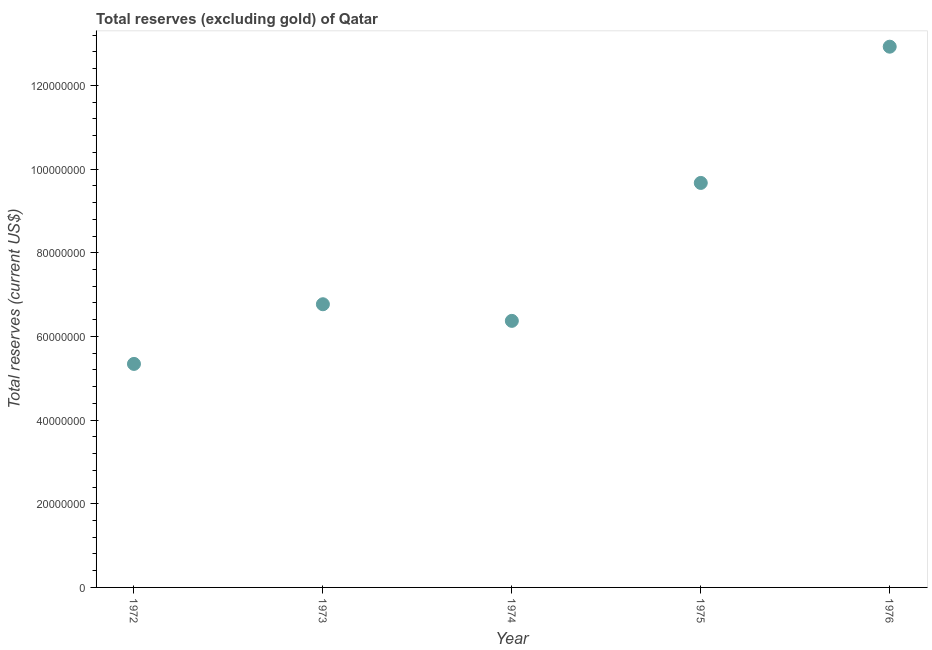What is the total reserves (excluding gold) in 1972?
Provide a short and direct response. 5.34e+07. Across all years, what is the maximum total reserves (excluding gold)?
Provide a short and direct response. 1.29e+08. Across all years, what is the minimum total reserves (excluding gold)?
Make the answer very short. 5.34e+07. In which year was the total reserves (excluding gold) maximum?
Your answer should be compact. 1976. In which year was the total reserves (excluding gold) minimum?
Ensure brevity in your answer.  1972. What is the sum of the total reserves (excluding gold)?
Offer a terse response. 4.11e+08. What is the difference between the total reserves (excluding gold) in 1972 and 1974?
Offer a very short reply. -1.03e+07. What is the average total reserves (excluding gold) per year?
Your answer should be very brief. 8.22e+07. What is the median total reserves (excluding gold)?
Offer a very short reply. 6.77e+07. What is the ratio of the total reserves (excluding gold) in 1974 to that in 1975?
Provide a short and direct response. 0.66. Is the difference between the total reserves (excluding gold) in 1973 and 1976 greater than the difference between any two years?
Provide a short and direct response. No. What is the difference between the highest and the second highest total reserves (excluding gold)?
Ensure brevity in your answer.  3.26e+07. What is the difference between the highest and the lowest total reserves (excluding gold)?
Give a very brief answer. 7.58e+07. In how many years, is the total reserves (excluding gold) greater than the average total reserves (excluding gold) taken over all years?
Make the answer very short. 2. How many dotlines are there?
Ensure brevity in your answer.  1. What is the difference between two consecutive major ticks on the Y-axis?
Give a very brief answer. 2.00e+07. Does the graph contain grids?
Offer a very short reply. No. What is the title of the graph?
Provide a succinct answer. Total reserves (excluding gold) of Qatar. What is the label or title of the Y-axis?
Your answer should be compact. Total reserves (current US$). What is the Total reserves (current US$) in 1972?
Ensure brevity in your answer.  5.34e+07. What is the Total reserves (current US$) in 1973?
Make the answer very short. 6.77e+07. What is the Total reserves (current US$) in 1974?
Offer a terse response. 6.37e+07. What is the Total reserves (current US$) in 1975?
Give a very brief answer. 9.67e+07. What is the Total reserves (current US$) in 1976?
Your response must be concise. 1.29e+08. What is the difference between the Total reserves (current US$) in 1972 and 1973?
Offer a very short reply. -1.43e+07. What is the difference between the Total reserves (current US$) in 1972 and 1974?
Provide a short and direct response. -1.03e+07. What is the difference between the Total reserves (current US$) in 1972 and 1975?
Make the answer very short. -4.33e+07. What is the difference between the Total reserves (current US$) in 1972 and 1976?
Ensure brevity in your answer.  -7.58e+07. What is the difference between the Total reserves (current US$) in 1973 and 1974?
Keep it short and to the point. 3.97e+06. What is the difference between the Total reserves (current US$) in 1973 and 1975?
Your response must be concise. -2.90e+07. What is the difference between the Total reserves (current US$) in 1973 and 1976?
Provide a short and direct response. -6.16e+07. What is the difference between the Total reserves (current US$) in 1974 and 1975?
Your answer should be compact. -3.30e+07. What is the difference between the Total reserves (current US$) in 1974 and 1976?
Give a very brief answer. -6.55e+07. What is the difference between the Total reserves (current US$) in 1975 and 1976?
Offer a very short reply. -3.26e+07. What is the ratio of the Total reserves (current US$) in 1972 to that in 1973?
Provide a short and direct response. 0.79. What is the ratio of the Total reserves (current US$) in 1972 to that in 1974?
Make the answer very short. 0.84. What is the ratio of the Total reserves (current US$) in 1972 to that in 1975?
Your answer should be very brief. 0.55. What is the ratio of the Total reserves (current US$) in 1972 to that in 1976?
Offer a very short reply. 0.41. What is the ratio of the Total reserves (current US$) in 1973 to that in 1974?
Ensure brevity in your answer.  1.06. What is the ratio of the Total reserves (current US$) in 1973 to that in 1975?
Offer a terse response. 0.7. What is the ratio of the Total reserves (current US$) in 1973 to that in 1976?
Your answer should be very brief. 0.52. What is the ratio of the Total reserves (current US$) in 1974 to that in 1975?
Provide a short and direct response. 0.66. What is the ratio of the Total reserves (current US$) in 1974 to that in 1976?
Your answer should be compact. 0.49. What is the ratio of the Total reserves (current US$) in 1975 to that in 1976?
Your answer should be compact. 0.75. 